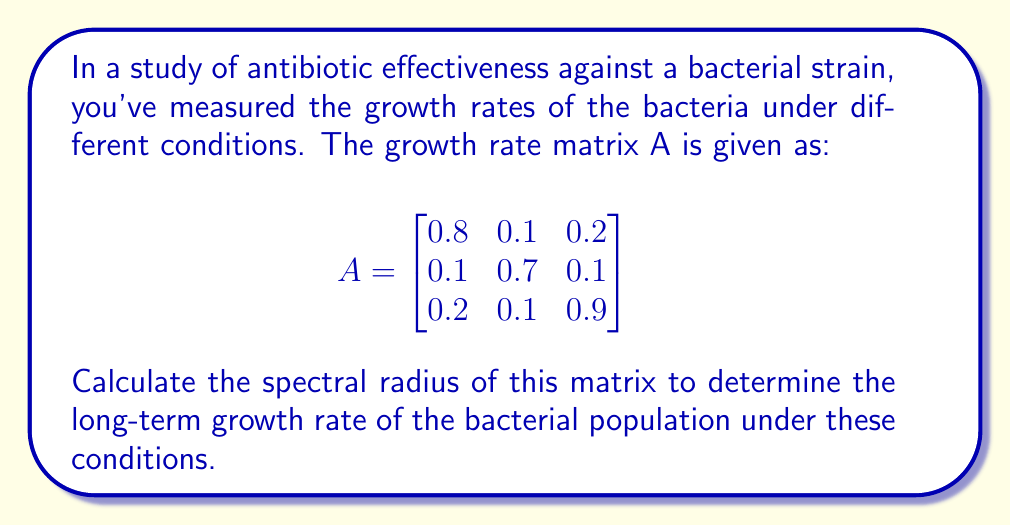Could you help me with this problem? To find the spectral radius of matrix A, we need to follow these steps:

1) First, calculate the characteristic polynomial of A:
   $det(A - \lambda I) = 0$

   $$\begin{vmatrix}
   0.8-\lambda & 0.1 & 0.2 \\
   0.1 & 0.7-\lambda & 0.1 \\
   0.2 & 0.1 & 0.9-\lambda
   \end{vmatrix} = 0$$

2) Expand the determinant:
   $(0.8-\lambda)(0.7-\lambda)(0.9-\lambda) - 0.1 \cdot 0.1 \cdot 0.2 - 0.2 \cdot 0.1 \cdot 0.1 - (0.8-\lambda) \cdot 0.1 \cdot 0.1 - 0.1 \cdot (0.9-\lambda) \cdot 0.1 - 0.2 \cdot (0.7-\lambda) \cdot 0.2 = 0$

3) Simplify:
   $-\lambda^3 + 2.4\lambda^2 - 1.858\lambda + 0.4596 = 0$

4) Solve this cubic equation. The roots are the eigenvalues of A. Using a numerical method or a calculator, we get:

   $\lambda_1 \approx 1.0392$
   $\lambda_2 \approx 0.6804$
   $\lambda_3 \approx 0.6804$

5) The spectral radius is the maximum absolute value of the eigenvalues:

   $\rho(A) = max(|\lambda_1|, |\lambda_2|, |\lambda_3|) = |\lambda_1| \approx 1.0392$
Answer: $1.0392$ 